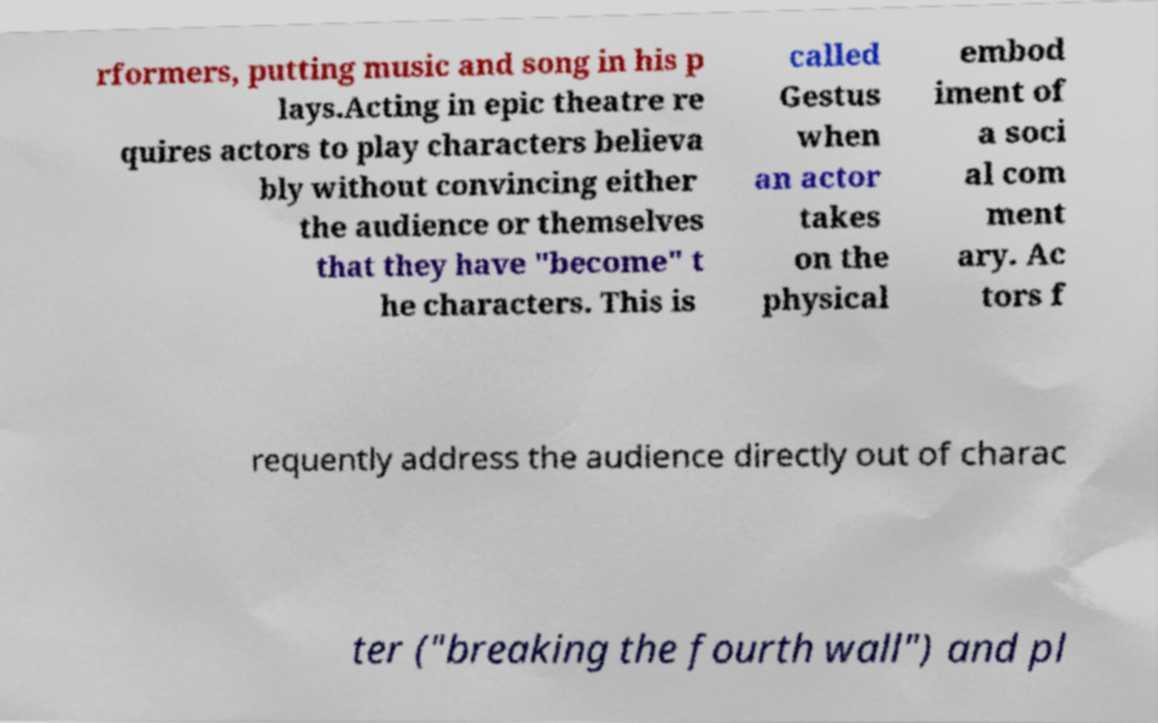There's text embedded in this image that I need extracted. Can you transcribe it verbatim? rformers, putting music and song in his p lays.Acting in epic theatre re quires actors to play characters believa bly without convincing either the audience or themselves that they have "become" t he characters. This is called Gestus when an actor takes on the physical embod iment of a soci al com ment ary. Ac tors f requently address the audience directly out of charac ter ("breaking the fourth wall") and pl 